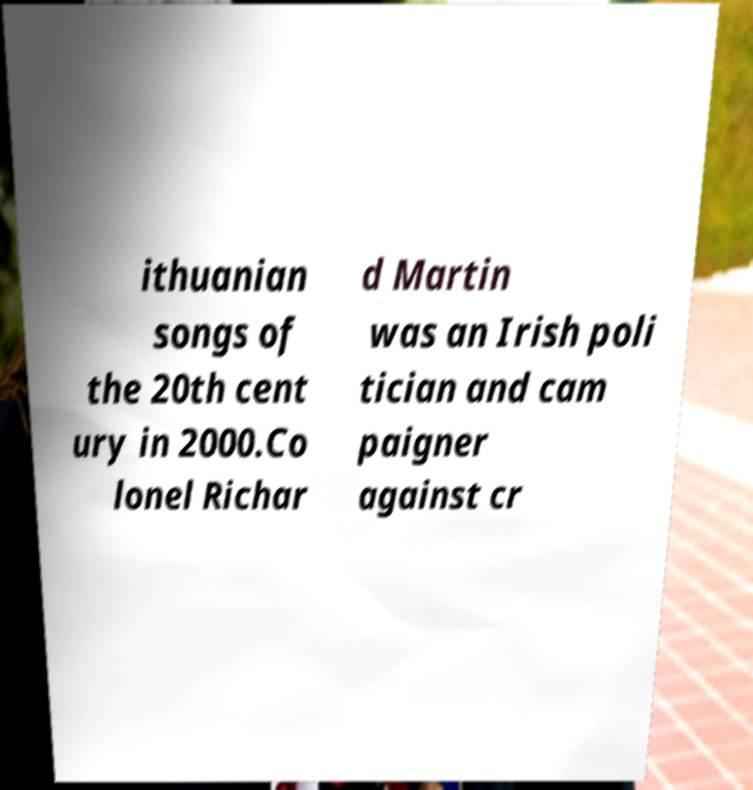Could you extract and type out the text from this image? ithuanian songs of the 20th cent ury in 2000.Co lonel Richar d Martin was an Irish poli tician and cam paigner against cr 